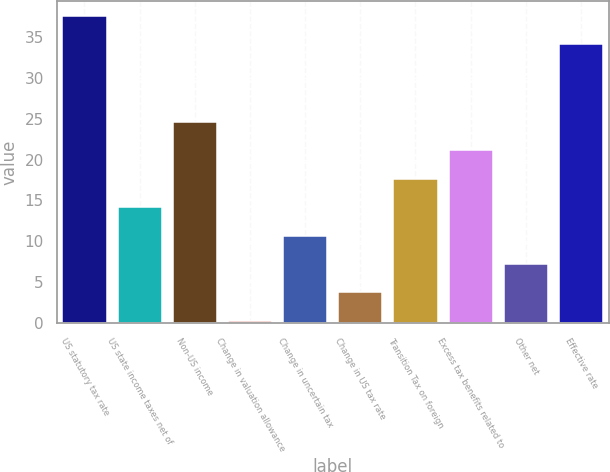Convert chart. <chart><loc_0><loc_0><loc_500><loc_500><bar_chart><fcel>US statutory tax rate<fcel>US state income taxes net of<fcel>Non-US income<fcel>Change in valuation allowance<fcel>Change in uncertain tax<fcel>Change in US tax rate<fcel>Transition Tax on foreign<fcel>Excess tax benefits related to<fcel>Other net<fcel>Effective rate<nl><fcel>37.57<fcel>14.18<fcel>24.59<fcel>0.3<fcel>10.71<fcel>3.77<fcel>17.65<fcel>21.12<fcel>7.24<fcel>34.1<nl></chart> 